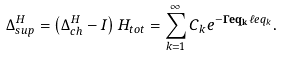<formula> <loc_0><loc_0><loc_500><loc_500>\Delta _ { s u p } ^ { H } = \left ( \Delta _ { c h } ^ { H } - I \right ) H _ { t o t } = \sum _ { k = 1 } ^ { \infty } C _ { k } e ^ { - \mathbf { \Gamma e q _ { k } } \ell e q _ { k } } .</formula> 